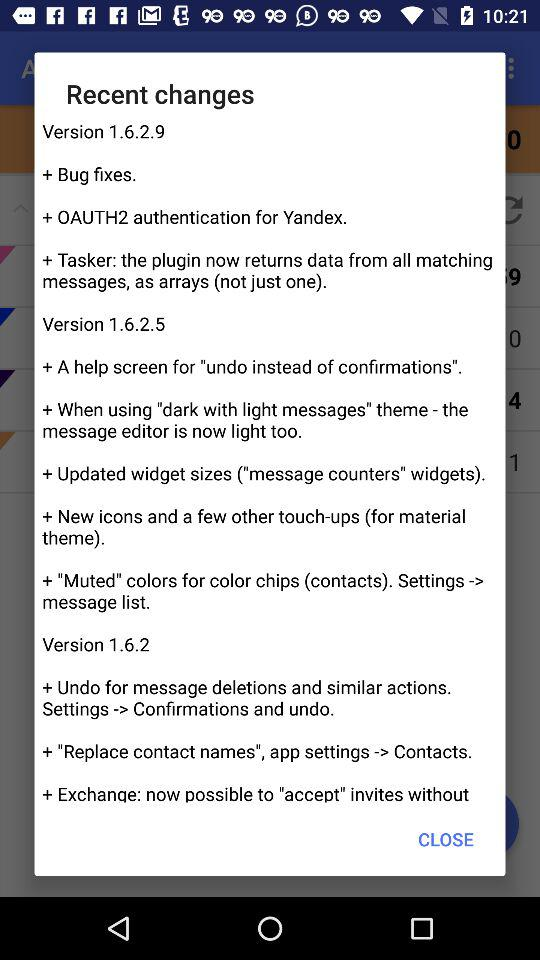Which version is given? The given versions are 1.6.2.9, 1.6.2.5 and 1.6.2. 